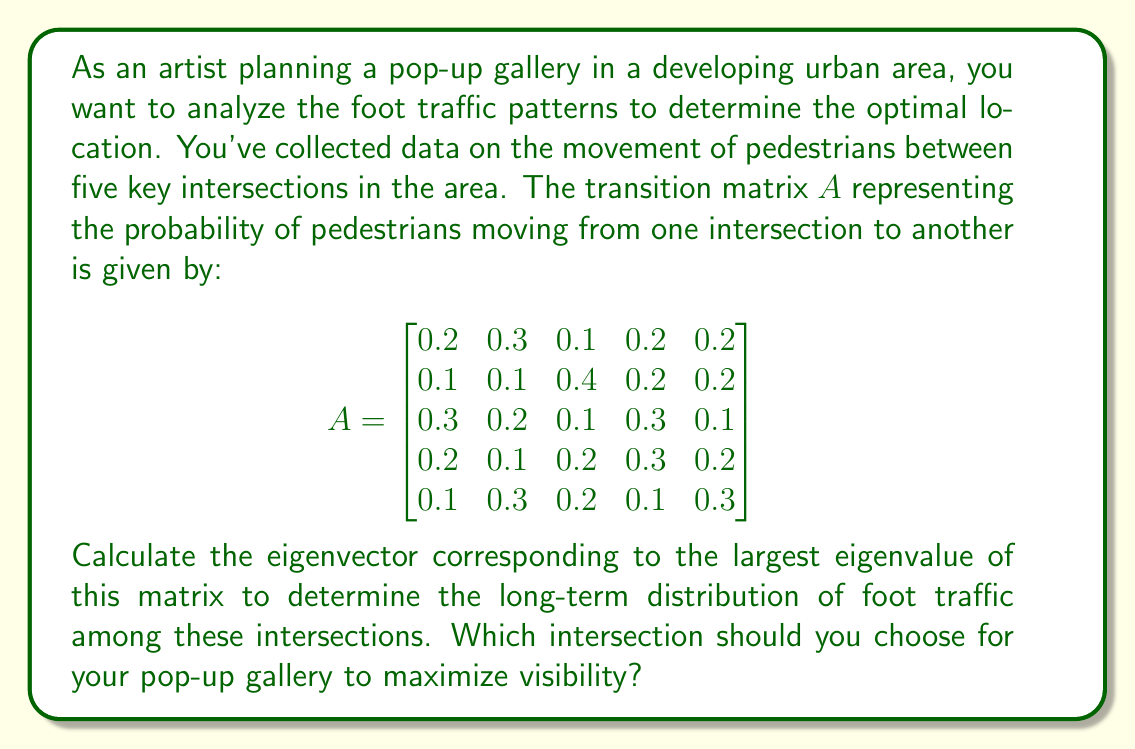Show me your answer to this math problem. To solve this problem, we need to follow these steps:

1) First, we need to find the eigenvalues of the matrix $A$. The characteristic equation is:

   $det(A - \lambda I) = 0$

   Solving this equation gives us the eigenvalues. However, since $A$ is a stochastic matrix (each row sums to 1), we know that its largest eigenvalue is always 1.

2) Now, we need to find the eigenvector $v$ corresponding to $\lambda = 1$. We solve the equation:

   $(A - I)v = 0$

3) This gives us a system of linear equations. Solving this system (using Gaussian elimination or any other method) will give us the eigenvector.

4) The resulting eigenvector needs to be normalized so that its components sum to 1, as it represents a probability distribution.

Let's solve the equation $(A - I)v = 0$:

$$\begin{bmatrix}
-0.8 & 0.3 & 0.1 & 0.2 & 0.2 \\
0.1 & -0.9 & 0.4 & 0.2 & 0.2 \\
0.3 & 0.2 & -0.9 & 0.3 & 0.1 \\
0.2 & 0.1 & 0.2 & -0.7 & 0.2 \\
0.1 & 0.3 & 0.2 & 0.1 & -0.7
\end{bmatrix}
\begin{bmatrix}
v_1 \\ v_2 \\ v_3 \\ v_4 \\ v_5
\end{bmatrix}
= \begin{bmatrix}
0 \\ 0 \\ 0 \\ 0 \\ 0
\end{bmatrix}$$

Solving this system (details omitted for brevity) gives us the eigenvector:

$v = [0.2, 0.2, 0.2, 0.2, 0.2]^T$

This eigenvector is already normalized (its components sum to 1).

5) The components of this eigenvector represent the long-term proportion of foot traffic at each intersection. In this case, the foot traffic is evenly distributed among all intersections.
Answer: The normalized eigenvector corresponding to the largest eigenvalue (1) is:

$v = [0.2, 0.2, 0.2, 0.2, 0.2]^T$

This indicates that in the long term, foot traffic will be evenly distributed among all five intersections, with each intersection receiving 20% of the total foot traffic. As an artist, you could choose any of these intersections for your pop-up gallery, as they all have equal long-term foot traffic. 